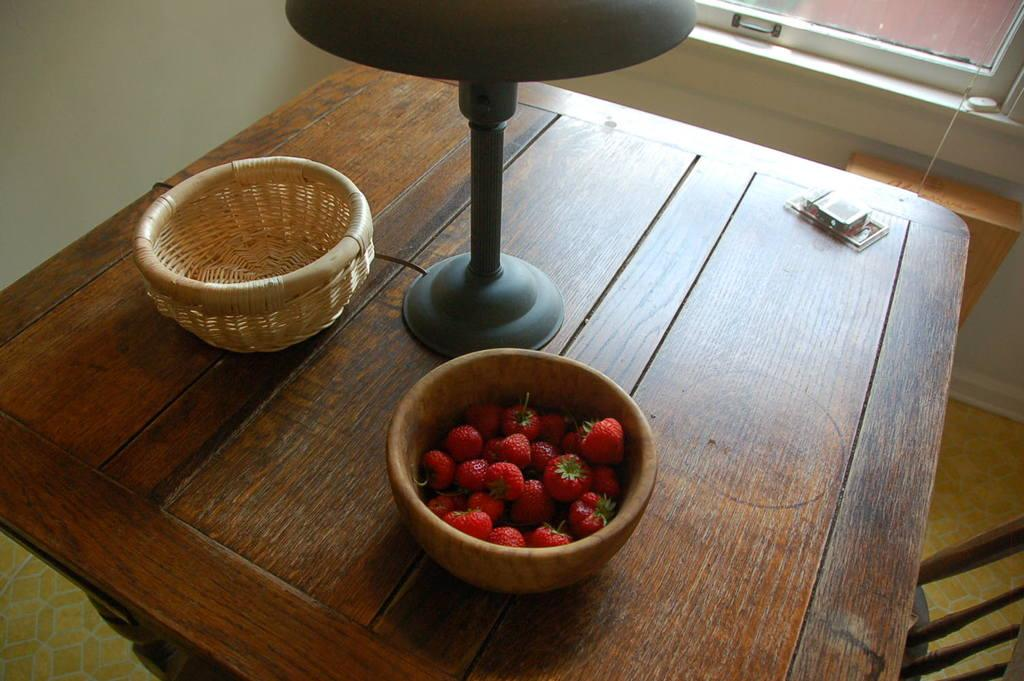What is in the bowl that is visible in the image? There is an empty bowl in the image. What is in the other bowl that is visible in the image? There is a bowl of strawberries in the image. What can be seen on the table in the image? There is a lamp and an object on the table in the image. What is visible in the background of the image? There is a wall, a chair, and a window in the background of the image. How many faces can be seen on the strawberries in the image? There are no faces present on the strawberries in the image, as strawberries are fruit and do not have faces. 